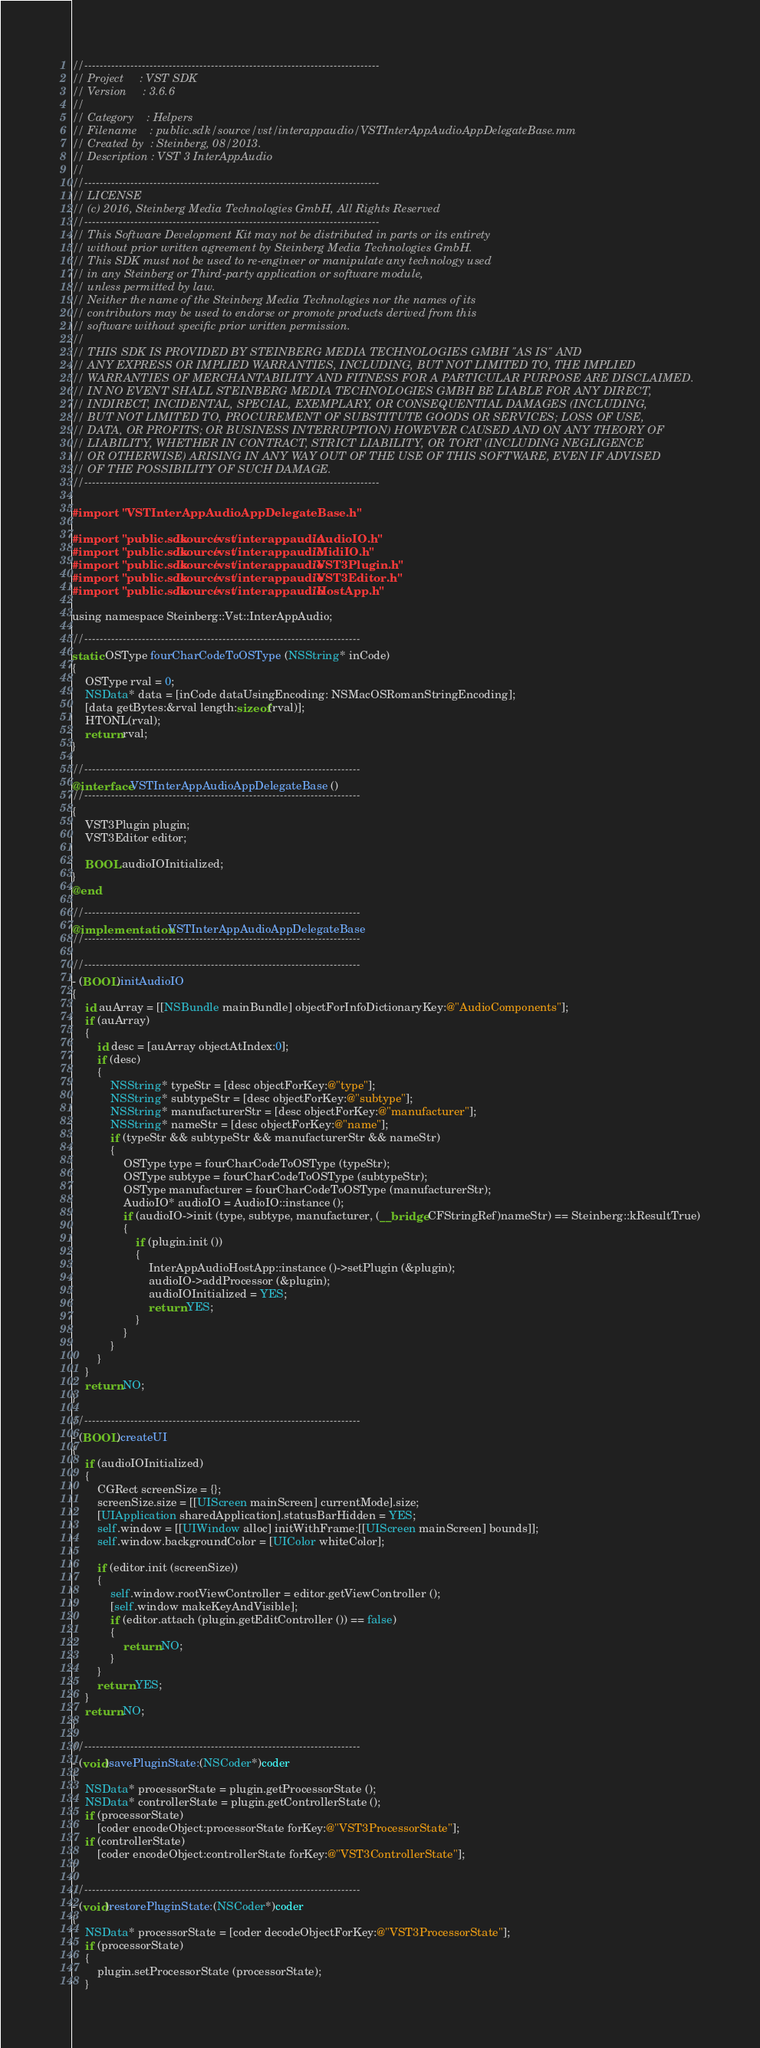<code> <loc_0><loc_0><loc_500><loc_500><_ObjectiveC_>//-----------------------------------------------------------------------------
// Project     : VST SDK
// Version     : 3.6.6
//
// Category    : Helpers
// Filename    : public.sdk/source/vst/interappaudio/VSTInterAppAudioAppDelegateBase.mm
// Created by  : Steinberg, 08/2013.
// Description : VST 3 InterAppAudio
//
//-----------------------------------------------------------------------------
// LICENSE
// (c) 2016, Steinberg Media Technologies GmbH, All Rights Reserved
//-----------------------------------------------------------------------------
// This Software Development Kit may not be distributed in parts or its entirety
// without prior written agreement by Steinberg Media Technologies GmbH.
// This SDK must not be used to re-engineer or manipulate any technology used
// in any Steinberg or Third-party application or software module,
// unless permitted by law.
// Neither the name of the Steinberg Media Technologies nor the names of its
// contributors may be used to endorse or promote products derived from this
// software without specific prior written permission.
//
// THIS SDK IS PROVIDED BY STEINBERG MEDIA TECHNOLOGIES GMBH "AS IS" AND
// ANY EXPRESS OR IMPLIED WARRANTIES, INCLUDING, BUT NOT LIMITED TO, THE IMPLIED
// WARRANTIES OF MERCHANTABILITY AND FITNESS FOR A PARTICULAR PURPOSE ARE DISCLAIMED.
// IN NO EVENT SHALL STEINBERG MEDIA TECHNOLOGIES GMBH BE LIABLE FOR ANY DIRECT,
// INDIRECT, INCIDENTAL, SPECIAL, EXEMPLARY, OR CONSEQUENTIAL DAMAGES (INCLUDING,
// BUT NOT LIMITED TO, PROCUREMENT OF SUBSTITUTE GOODS OR SERVICES; LOSS OF USE,
// DATA, OR PROFITS; OR BUSINESS INTERRUPTION) HOWEVER CAUSED AND ON ANY THEORY OF
// LIABILITY, WHETHER IN CONTRACT, STRICT LIABILITY, OR TORT (INCLUDING NEGLIGENCE
// OR OTHERWISE) ARISING IN ANY WAY OUT OF THE USE OF THIS SOFTWARE, EVEN IF ADVISED
// OF THE POSSIBILITY OF SUCH DAMAGE.
//-----------------------------------------------------------------------------

#import "VSTInterAppAudioAppDelegateBase.h"

#import "public.sdk/source/vst/interappaudio/AudioIO.h"
#import "public.sdk/source/vst/interappaudio/MidiIO.h"
#import "public.sdk/source/vst/interappaudio/VST3Plugin.h"
#import "public.sdk/source/vst/interappaudio/VST3Editor.h"
#import "public.sdk/source/vst/interappaudio/HostApp.h"

using namespace Steinberg::Vst::InterAppAudio;

//------------------------------------------------------------------------
static OSType fourCharCodeToOSType (NSString* inCode)
{
	OSType rval = 0;
	NSData* data = [inCode dataUsingEncoding: NSMacOSRomanStringEncoding];
	[data getBytes:&rval length:sizeof(rval)];
	HTONL(rval);
	return rval;
}

//------------------------------------------------------------------------
@interface VSTInterAppAudioAppDelegateBase ()
//------------------------------------------------------------------------
{
	VST3Plugin plugin;
	VST3Editor editor;
	
	BOOL audioIOInitialized;
}
@end

//------------------------------------------------------------------------
@implementation VSTInterAppAudioAppDelegateBase
//------------------------------------------------------------------------

//------------------------------------------------------------------------
- (BOOL)initAudioIO
{
	id auArray = [[NSBundle mainBundle] objectForInfoDictionaryKey:@"AudioComponents"];
	if (auArray)
	{
		id desc = [auArray objectAtIndex:0];
		if (desc)
		{
			NSString* typeStr = [desc objectForKey:@"type"];
			NSString* subtypeStr = [desc objectForKey:@"subtype"];
			NSString* manufacturerStr = [desc objectForKey:@"manufacturer"];
			NSString* nameStr = [desc objectForKey:@"name"];
			if (typeStr && subtypeStr && manufacturerStr && nameStr)
			{
				OSType type = fourCharCodeToOSType (typeStr);
				OSType subtype = fourCharCodeToOSType (subtypeStr);
				OSType manufacturer = fourCharCodeToOSType (manufacturerStr);
				AudioIO* audioIO = AudioIO::instance ();
				if (audioIO->init (type, subtype, manufacturer, (__bridge CFStringRef)nameStr) == Steinberg::kResultTrue)
				{
					if (plugin.init ())
					{
						InterAppAudioHostApp::instance ()->setPlugin (&plugin);
						audioIO->addProcessor (&plugin);
						audioIOInitialized = YES;
						return YES;
					}
				}
			}
		}
	}
	return NO;
}

//------------------------------------------------------------------------
- (BOOL)createUI
{
	if (audioIOInitialized)
	{
		CGRect screenSize = {};
		screenSize.size = [[UIScreen mainScreen] currentMode].size;
		[UIApplication sharedApplication].statusBarHidden = YES;
		self.window = [[UIWindow alloc] initWithFrame:[[UIScreen mainScreen] bounds]];
		self.window.backgroundColor = [UIColor whiteColor];
		
		if (editor.init (screenSize))
		{
			self.window.rootViewController = editor.getViewController ();
			[self.window makeKeyAndVisible];
			if (editor.attach (plugin.getEditController ()) == false)
			{
				return NO;
			}
		}
		return YES;
	}
	return NO;
}

//------------------------------------------------------------------------
- (void)savePluginState:(NSCoder*)coder
{
	NSData* processorState = plugin.getProcessorState ();
	NSData* controllerState = plugin.getControllerState ();
	if (processorState)
		[coder encodeObject:processorState forKey:@"VST3ProcessorState"];
	if (controllerState)
		[coder encodeObject:controllerState forKey:@"VST3ControllerState"];
}

//------------------------------------------------------------------------
- (void)restorePluginState:(NSCoder*)coder
{
	NSData* processorState = [coder decodeObjectForKey:@"VST3ProcessorState"];
	if (processorState)
	{
		plugin.setProcessorState (processorState);
	}</code> 